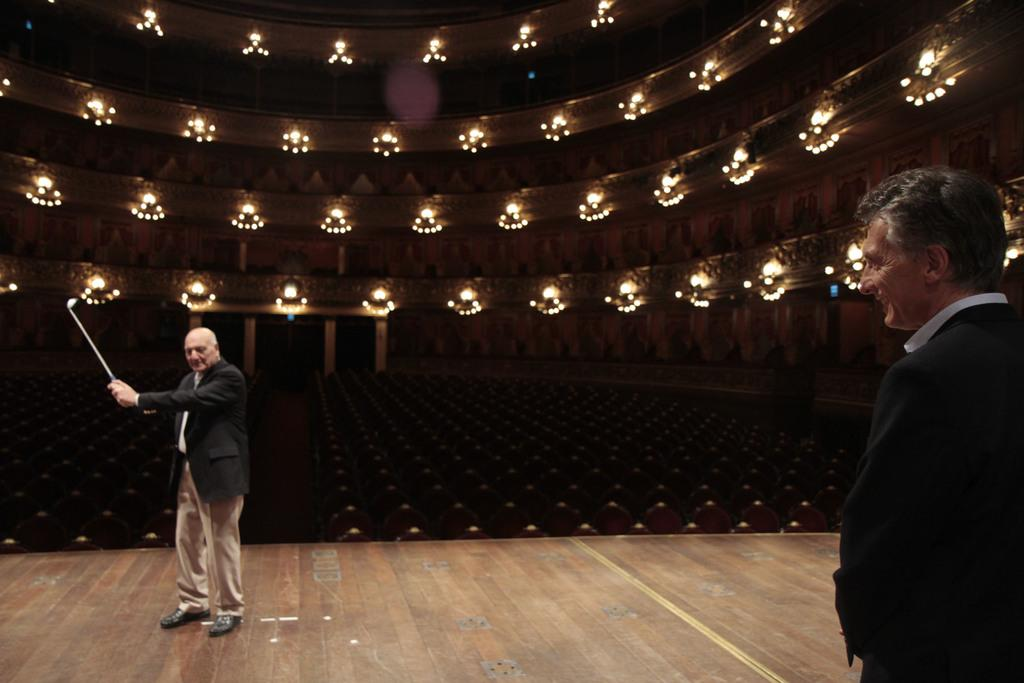Who is the main subject in the image? There is an old man in a suit in the image. What is the old man holding? The old man is holding a golf bat. Where is the old man located in the image? The old man is on a stage. Can you describe the setting of the image? There is another old man standing on the right side, there are lights over the ceiling, and there are many seats below the lights. What type of coat is the old man wearing in the image? The provided facts do not mention a coat; the old man is described as wearing a suit. How does the old man plan to use the golf bat during his trip? The provided facts do not mention a trip; the old man is on a stage holding a golf bat. 